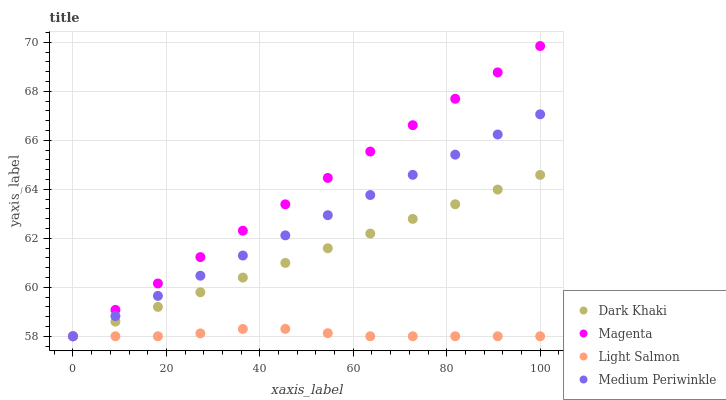Does Light Salmon have the minimum area under the curve?
Answer yes or no. Yes. Does Magenta have the maximum area under the curve?
Answer yes or no. Yes. Does Medium Periwinkle have the minimum area under the curve?
Answer yes or no. No. Does Medium Periwinkle have the maximum area under the curve?
Answer yes or no. No. Is Dark Khaki the smoothest?
Answer yes or no. Yes. Is Light Salmon the roughest?
Answer yes or no. Yes. Is Magenta the smoothest?
Answer yes or no. No. Is Magenta the roughest?
Answer yes or no. No. Does Dark Khaki have the lowest value?
Answer yes or no. Yes. Does Magenta have the highest value?
Answer yes or no. Yes. Does Medium Periwinkle have the highest value?
Answer yes or no. No. Does Dark Khaki intersect Medium Periwinkle?
Answer yes or no. Yes. Is Dark Khaki less than Medium Periwinkle?
Answer yes or no. No. Is Dark Khaki greater than Medium Periwinkle?
Answer yes or no. No. 